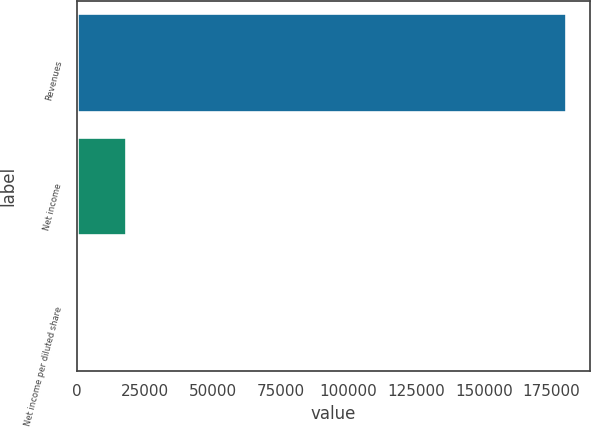Convert chart. <chart><loc_0><loc_0><loc_500><loc_500><bar_chart><fcel>Revenues<fcel>Net income<fcel>Net income per diluted share<nl><fcel>180155<fcel>18015.6<fcel>0.11<nl></chart> 